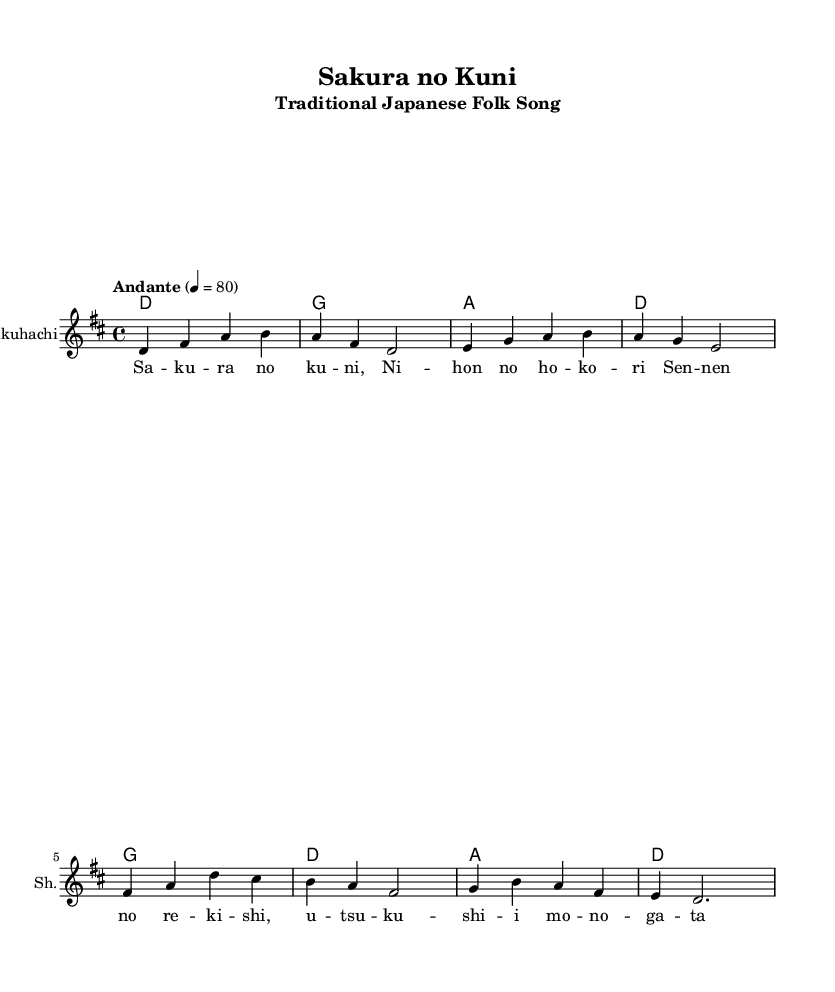What is the key signature of this music? The key signature is indicated at the beginning of the score and shows two sharps, which corresponds to D major.
Answer: D major What is the time signature? The time signature is located at the beginning of the sheet music, represented as 4 over 4, indicating four beats per measure.
Answer: 4/4 What is the tempo marking given in the score? The tempo marking is "Andante" followed by a metronome mark of 80, indicating a moderate pace.
Answer: Andante How many measures are in the melody? By counting each segment in the melody section, there are four measures after analyzing the rhythm and notation.
Answer: Four What instrument is indicated for the melodic part? The instrument name is specified on the staff as "Shakuhachi," which is a traditional Japanese bamboo flute.
Answer: Shakuhachi What is the first lyric of the song? The first lyric of the song is listed in the lyrics section and starts with "Sa," related to the title theme of cherry blossoms.
Answer: Sa What cultural significance does this song hold? The song is about cherry blossoms, a symbol of beauty and the transient nature of life in Japanese culture, representing national heritage.
Answer: Cherry blossoms 